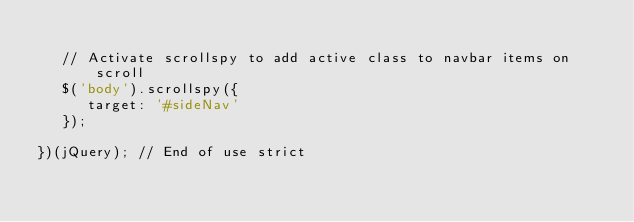Convert code to text. <code><loc_0><loc_0><loc_500><loc_500><_JavaScript_>
   // Activate scrollspy to add active class to navbar items on scroll
   $('body').scrollspy({
      target: '#sideNav'
   });

})(jQuery); // End of use strict
</code> 